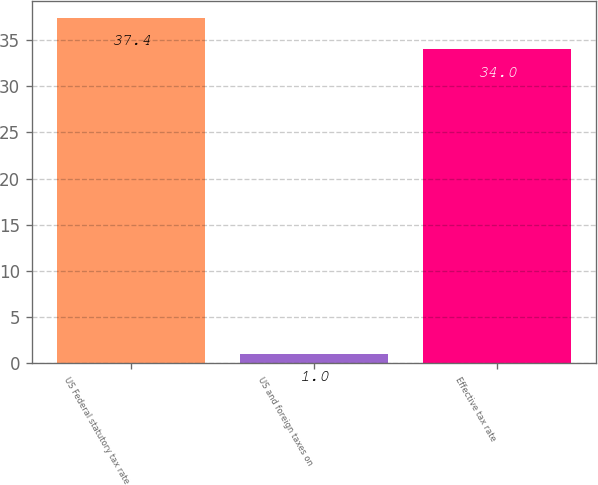<chart> <loc_0><loc_0><loc_500><loc_500><bar_chart><fcel>US Federal statutory tax rate<fcel>US and foreign taxes on<fcel>Effective tax rate<nl><fcel>37.4<fcel>1<fcel>34<nl></chart> 